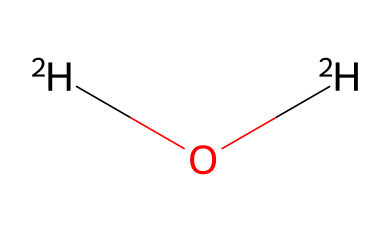What is the main element in this chemical? The chemical structure shows two hydrogen atoms and one oxygen atom. The presence of hydrogen, indicated by the notation [2H], means that hydrogen is the main element.
Answer: hydrogen How many hydrogen atoms are in this molecule? The SMILES representation shows [2H]O[2H], which indicates there are two hydrogen atoms in total in this molecule.
Answer: two What type of water is represented by this structure? The presence of deuterium ([2H]) in this molecule indicates that it is heavy water, as ordinary water contains light hydrogen.
Answer: heavy water What is the molecular formula for this chemical? The SMILES code corresponds to a structure with two deuterium atoms and one oxygen atom, which can be expressed in the molecular formula as D2O.
Answer: D2O Why is this chemical significant in nuclear power plants? Heavy water (D2O) acts as a neutron moderator, slowing down neutrons to facilitate the nuclear fission process in reactors, which is why it is significant.
Answer: neutron moderator What differentiates this chemical from regular water? The presence of deuterium instead of regular hydrogen is what differentiates heavy water (D2O) from regular water (H2O).
Answer: deuterium How many total atoms are in this chemical? The chemical structure shows two deuterium atoms and one oxygen atom, totaling three atoms in the molecule.
Answer: three 